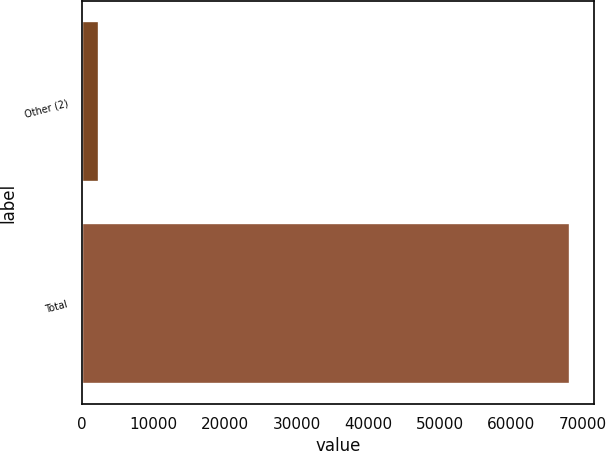Convert chart to OTSL. <chart><loc_0><loc_0><loc_500><loc_500><bar_chart><fcel>Other (2)<fcel>Total<nl><fcel>2400<fcel>68208<nl></chart> 